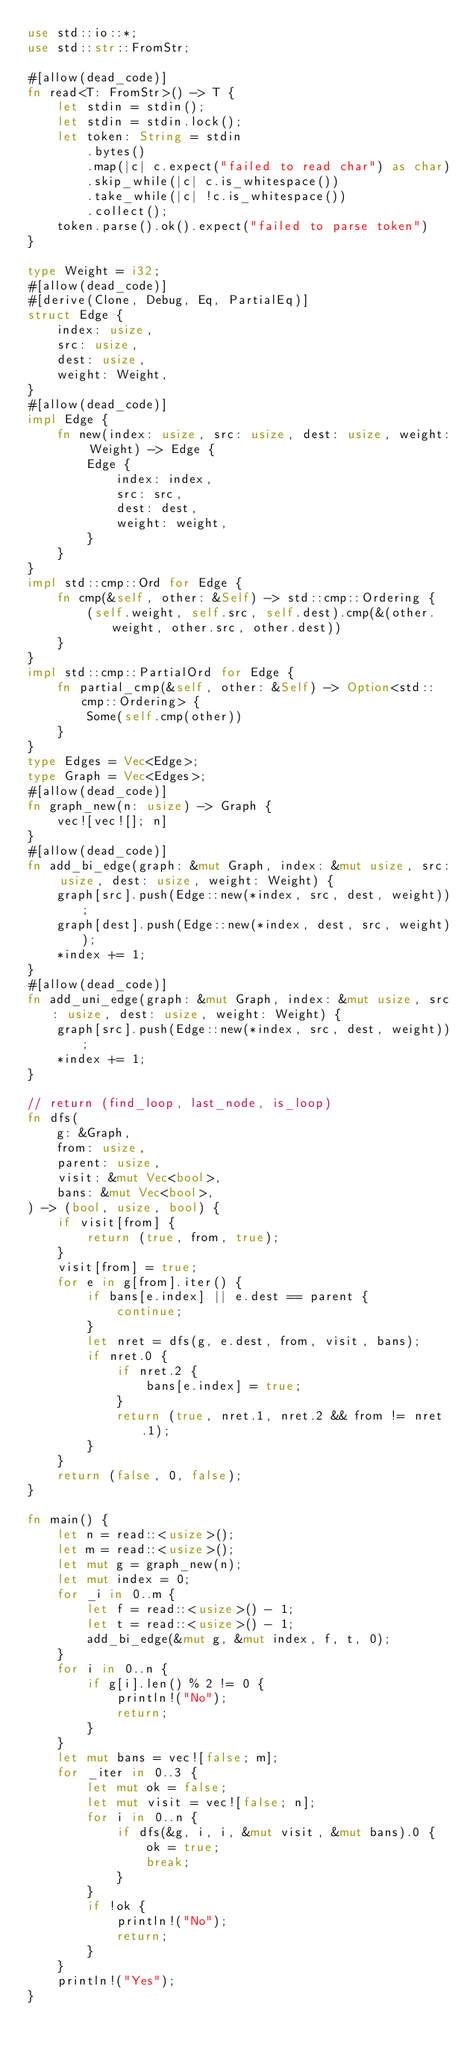Convert code to text. <code><loc_0><loc_0><loc_500><loc_500><_Rust_>use std::io::*;
use std::str::FromStr;

#[allow(dead_code)]
fn read<T: FromStr>() -> T {
    let stdin = stdin();
    let stdin = stdin.lock();
    let token: String = stdin
        .bytes()
        .map(|c| c.expect("failed to read char") as char)
        .skip_while(|c| c.is_whitespace())
        .take_while(|c| !c.is_whitespace())
        .collect();
    token.parse().ok().expect("failed to parse token")
}

type Weight = i32;
#[allow(dead_code)]
#[derive(Clone, Debug, Eq, PartialEq)]
struct Edge {
    index: usize,
    src: usize,
    dest: usize,
    weight: Weight,
}
#[allow(dead_code)]
impl Edge {
    fn new(index: usize, src: usize, dest: usize, weight: Weight) -> Edge {
        Edge {
            index: index,
            src: src,
            dest: dest,
            weight: weight,
        }
    }
}
impl std::cmp::Ord for Edge {
    fn cmp(&self, other: &Self) -> std::cmp::Ordering {
        (self.weight, self.src, self.dest).cmp(&(other.weight, other.src, other.dest))
    }
}
impl std::cmp::PartialOrd for Edge {
    fn partial_cmp(&self, other: &Self) -> Option<std::cmp::Ordering> {
        Some(self.cmp(other))
    }
}
type Edges = Vec<Edge>;
type Graph = Vec<Edges>;
#[allow(dead_code)]
fn graph_new(n: usize) -> Graph {
    vec![vec![]; n]
}
#[allow(dead_code)]
fn add_bi_edge(graph: &mut Graph, index: &mut usize, src: usize, dest: usize, weight: Weight) {
    graph[src].push(Edge::new(*index, src, dest, weight));
    graph[dest].push(Edge::new(*index, dest, src, weight));
    *index += 1;
}
#[allow(dead_code)]
fn add_uni_edge(graph: &mut Graph, index: &mut usize, src: usize, dest: usize, weight: Weight) {
    graph[src].push(Edge::new(*index, src, dest, weight));
    *index += 1;
}

// return (find_loop, last_node, is_loop)
fn dfs(
    g: &Graph,
    from: usize,
    parent: usize,
    visit: &mut Vec<bool>,
    bans: &mut Vec<bool>,
) -> (bool, usize, bool) {
    if visit[from] {
        return (true, from, true);
    }
    visit[from] = true;
    for e in g[from].iter() {
        if bans[e.index] || e.dest == parent {
            continue;
        }
        let nret = dfs(g, e.dest, from, visit, bans);
        if nret.0 {
            if nret.2 {
                bans[e.index] = true;
            }
            return (true, nret.1, nret.2 && from != nret.1);
        }
    }
    return (false, 0, false);
}

fn main() {
    let n = read::<usize>();
    let m = read::<usize>();
    let mut g = graph_new(n);
    let mut index = 0;
    for _i in 0..m {
        let f = read::<usize>() - 1;
        let t = read::<usize>() - 1;
        add_bi_edge(&mut g, &mut index, f, t, 0);
    }
    for i in 0..n {
        if g[i].len() % 2 != 0 {
            println!("No");
            return;
        }
    }
    let mut bans = vec![false; m];
    for _iter in 0..3 {
        let mut ok = false;
        let mut visit = vec![false; n];
        for i in 0..n {
            if dfs(&g, i, i, &mut visit, &mut bans).0 {
                ok = true;
                break;
            }
        }
        if !ok {
            println!("No");
            return;
        }
    }
    println!("Yes");
}
</code> 